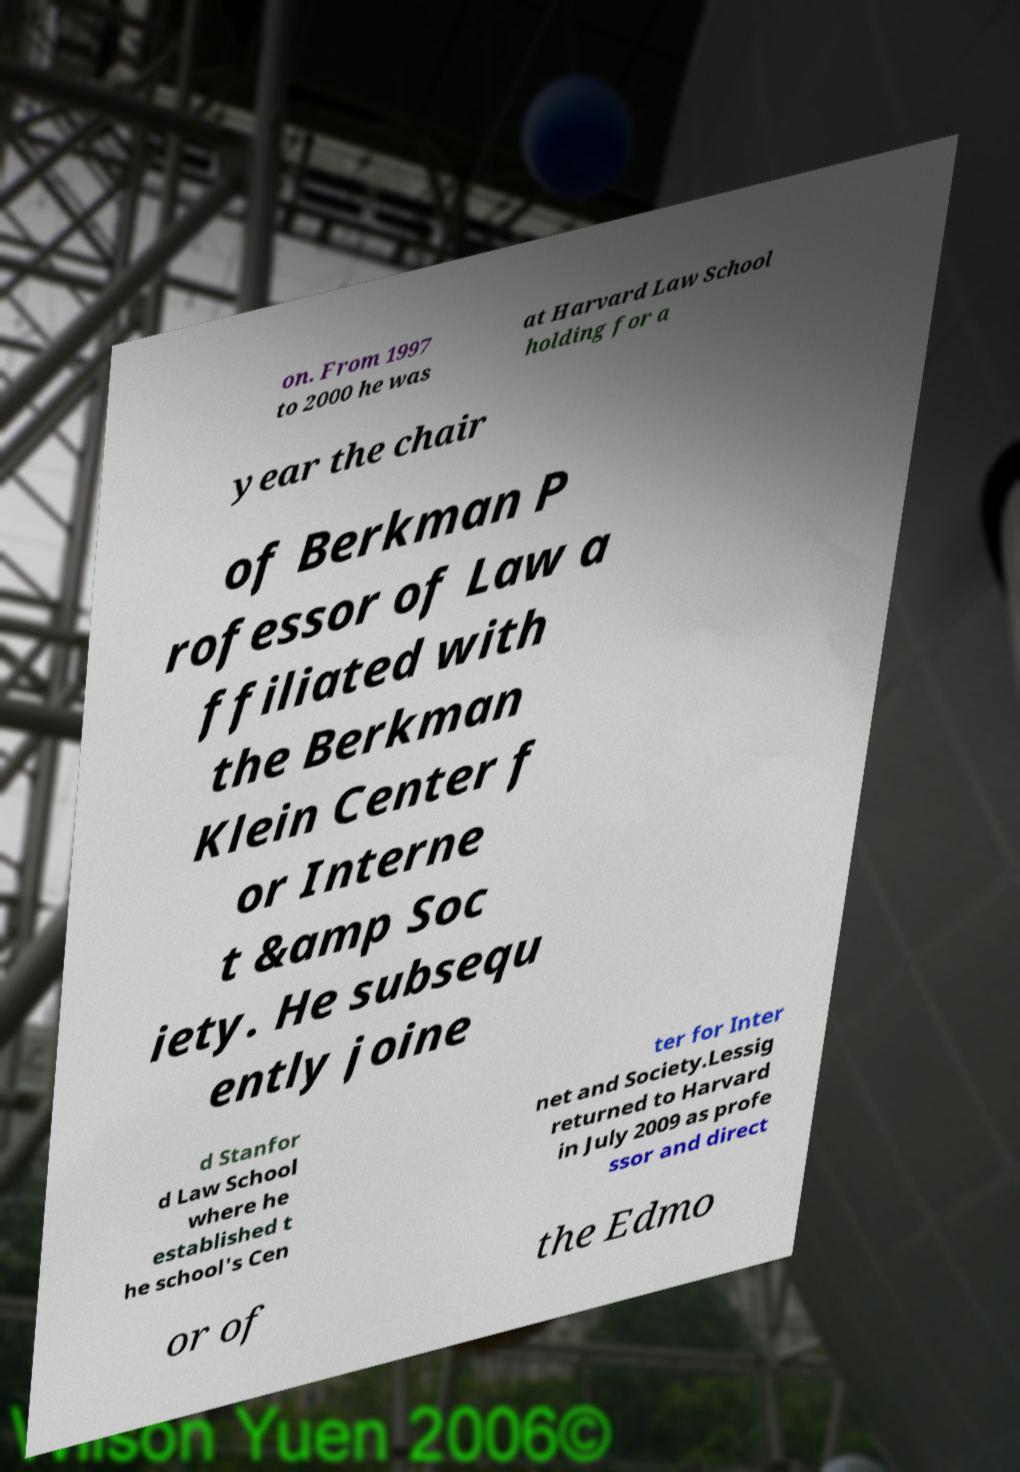There's text embedded in this image that I need extracted. Can you transcribe it verbatim? on. From 1997 to 2000 he was at Harvard Law School holding for a year the chair of Berkman P rofessor of Law a ffiliated with the Berkman Klein Center f or Interne t &amp Soc iety. He subsequ ently joine d Stanfor d Law School where he established t he school's Cen ter for Inter net and Society.Lessig returned to Harvard in July 2009 as profe ssor and direct or of the Edmo 